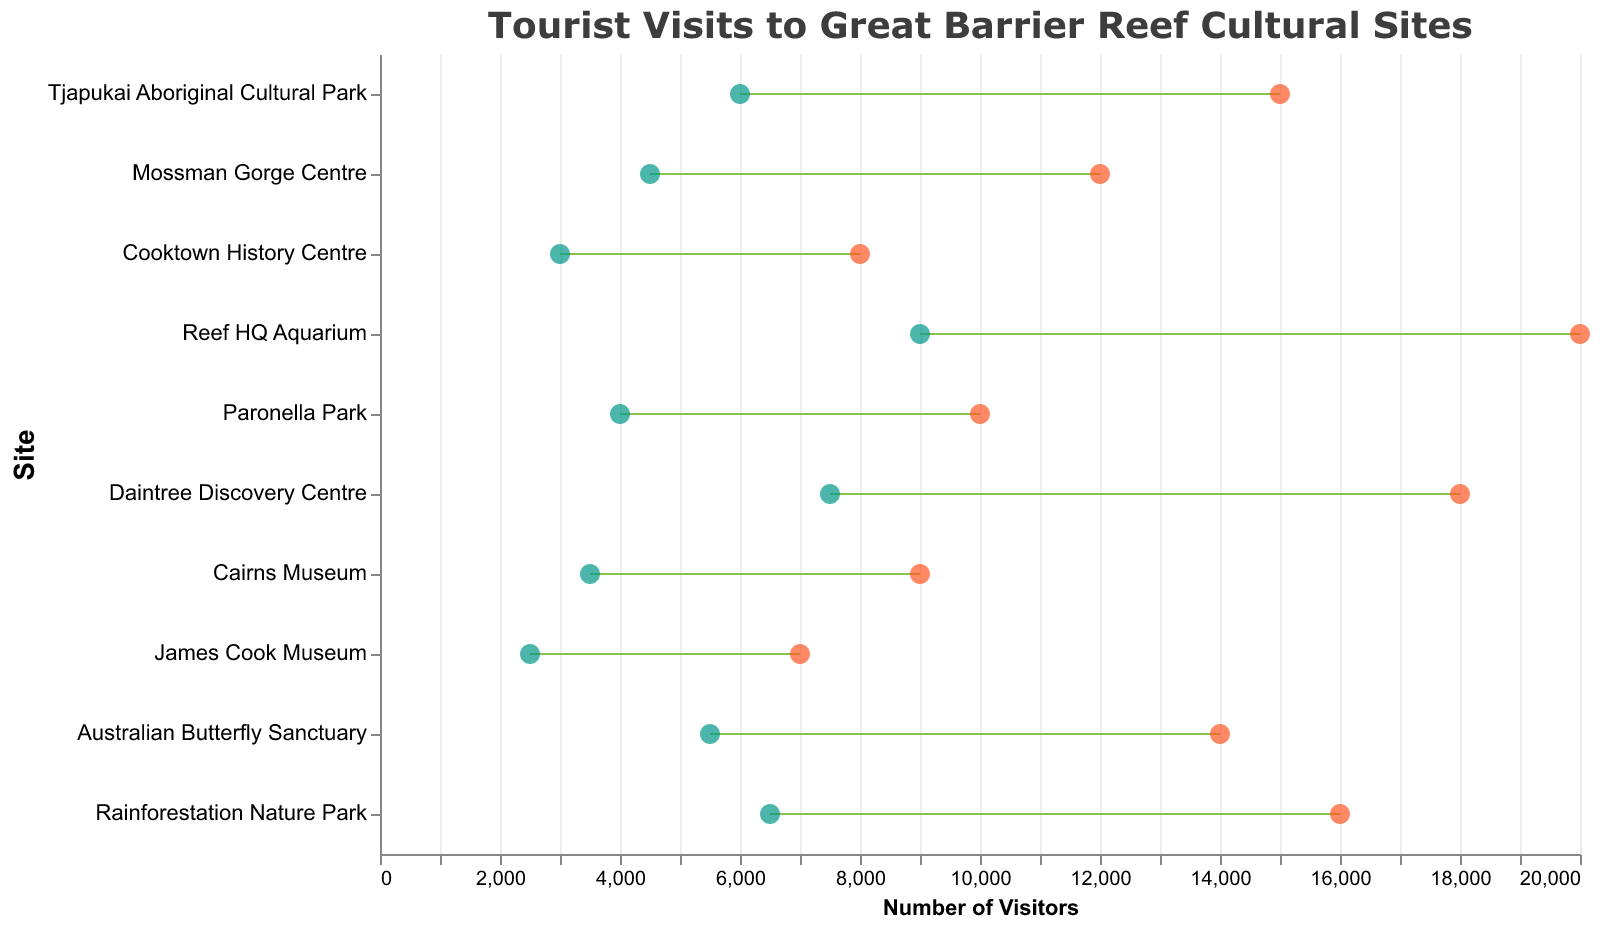What's the title of the plot? The title is prominently displayed at the top of the plot.
Answer: Tourist Visits to Great Barrier Reef Cultural Sites What are the colors used for the circles representing peak and off-peak seasons? The circles representing peak season are red, while those representing off-peak season are teal.
Answer: Peak Season: Red, Off-Peak Season: Teal Which site has the highest number of visitors in the peak season? The site with the highest number of visitors in the peak season is represented by the circle furthest to the right on the x-axis for peak season. This site is Reef HQ Aquarium.
Answer: Reef HQ Aquarium Which site has the smallest difference in the number of visitors between peak and off-peak seasons? To determine the smallest difference, look for the site with the shortest horizontal line (dumbbell). This site is the Cairns Museum.
Answer: Cairns Museum Is there any site that has more than double the number of visitors in peak season compared to off-peak season? By comparing peak and off-peak values for each site, find if the peak season value is more than twice the off-peak value. Tjapukai Aboriginal Cultural Park, Cooktown History Centre, Paronella Park, and James Cook Museum all meet this criterion.
Answer: Yes, Tjapukai Aboriginal Cultural Park, Cooktown History Centre, Paronella Park, and James Cook Museum What is the total number of visitors in the off-peak season for the Daintree Discovery Centre and Rainforestation Nature Park combined? Sum the off-peak visitors for both sites: 7500 (Daintree Discovery Centre) + 6500 (Rainforestation Nature Park) = 14000.
Answer: 14000 Which site has the maximum number of visitors in the off-peak season? The site with the highest number in the off-peak season is on the right-most side of the dumbbell plot in the off-peak season values. This site is Reef HQ Aquarium.
Answer: Reef HQ Aquarium How many total visitors did the Cooktown History Centre receive through both peak and off-peak seasons combined? Add the peak and off-peak visitors for the Cooktown History Centre: 8000 (Peak) + 3000 (Off-Peak) = 11000.
Answer: 11000 Which site shows the most significant drop in visitors from peak to off-peak season? The site with the longest horizontal distance between circles represents the biggest drop. This site is Reef HQ Aquarium.
Answer: Reef HQ Aquarium How many sites have more than 10,000 visitors in the peak season? Count the number of sites where the peak season visitors number exceeds 10,000. These sites are Tjapukai Aboriginal Cultural Park, Reef HQ Aquarium, Daintree Discovery Centre, Australian Butterfly Sanctuary, and Rainforestation Nature Park.
Answer: 5 